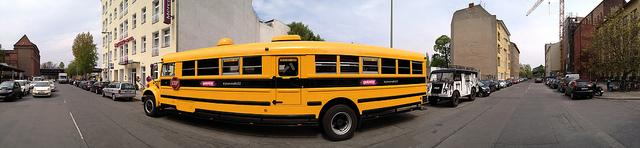What is this yellow bus doing? turning 